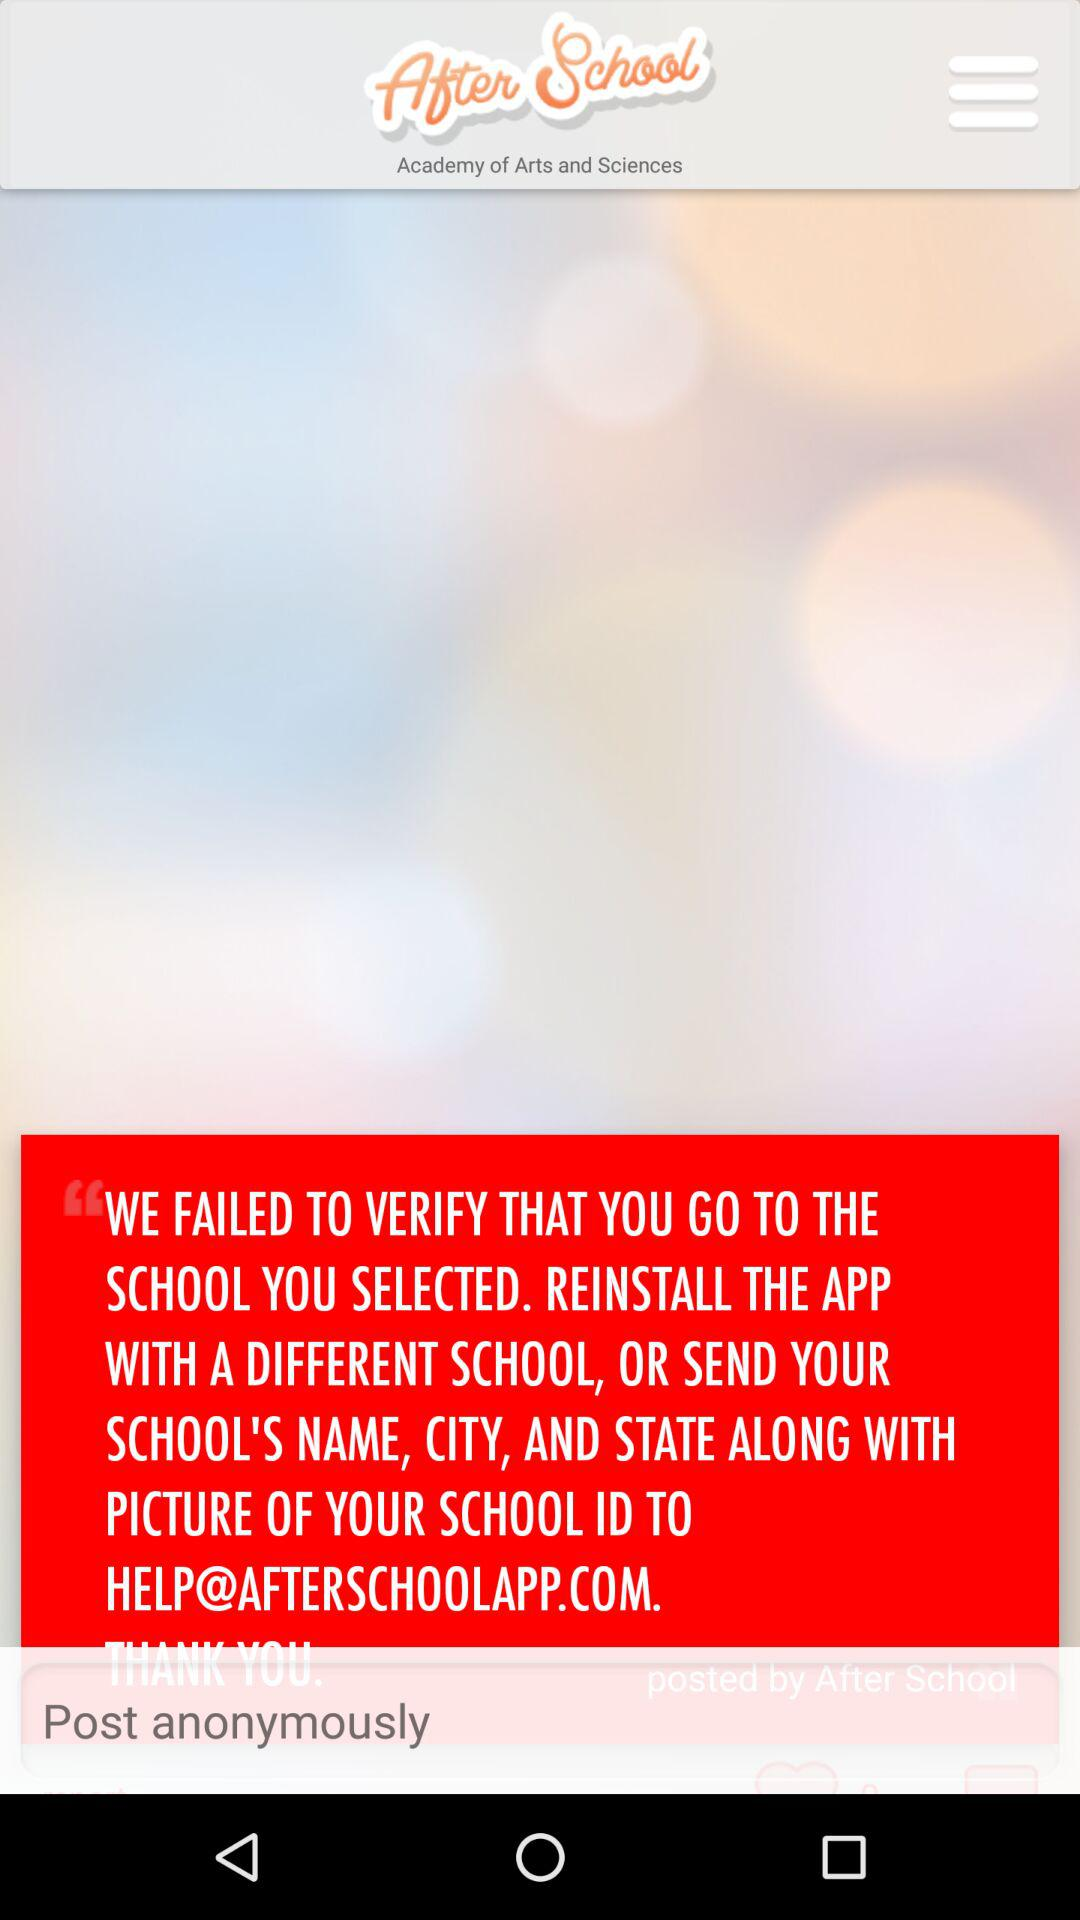What is the email address? The email address is help@afterschoolapp.com. 